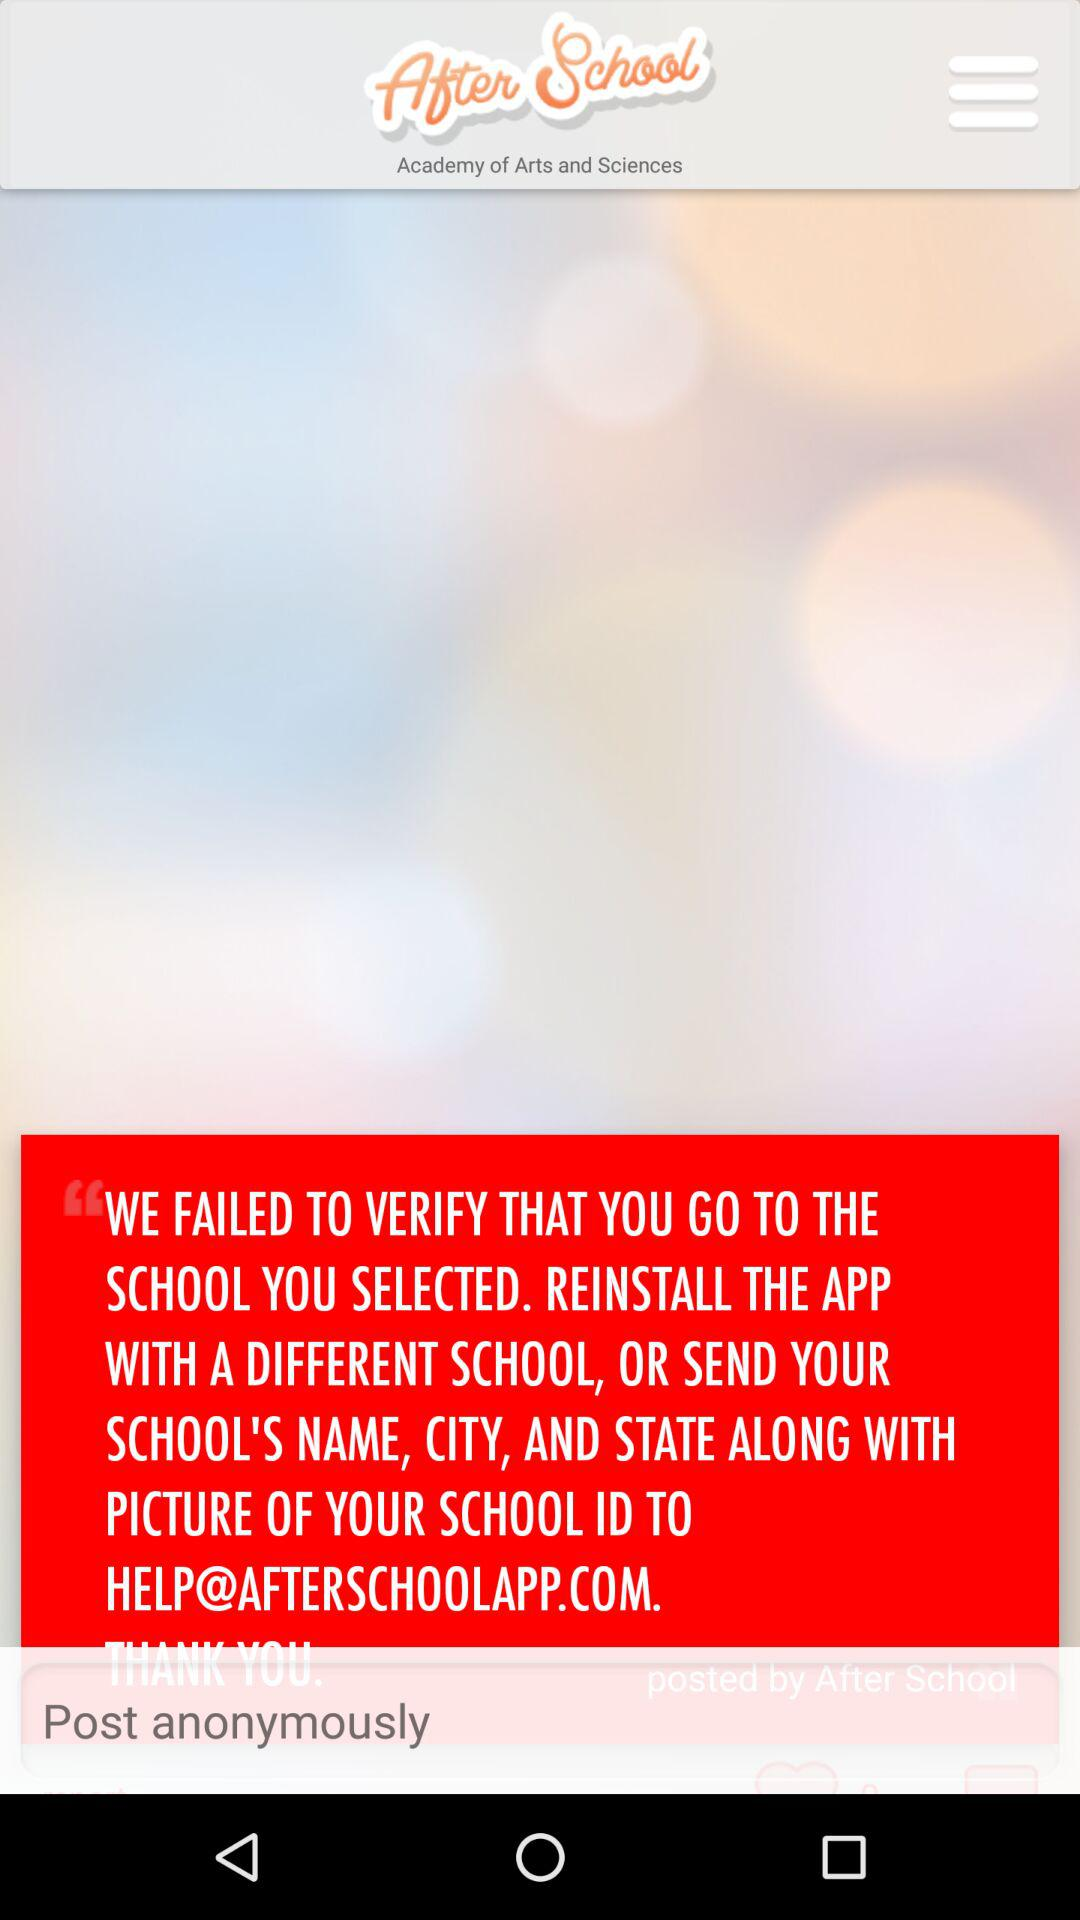What is the email address? The email address is help@afterschoolapp.com. 